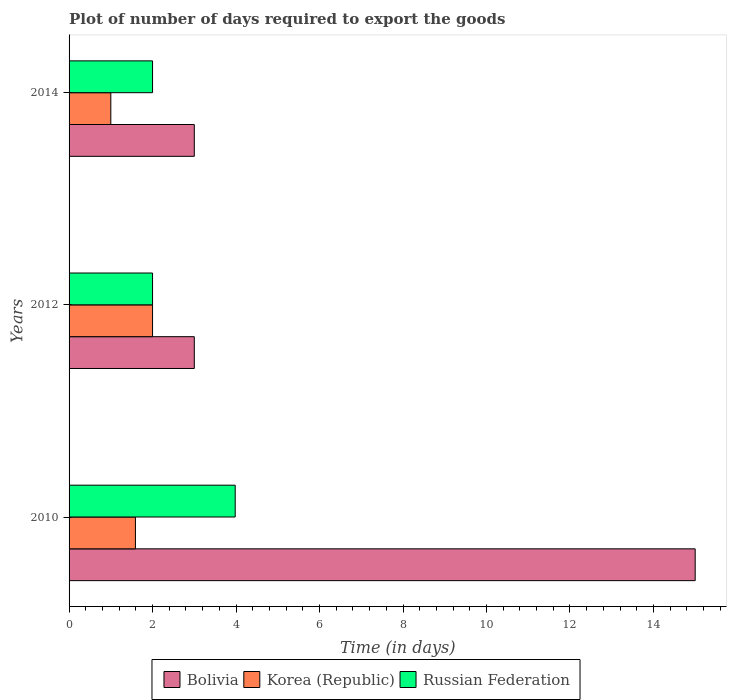How many different coloured bars are there?
Offer a very short reply. 3. How many groups of bars are there?
Your answer should be very brief. 3. How many bars are there on the 1st tick from the top?
Keep it short and to the point. 3. What is the label of the 1st group of bars from the top?
Your answer should be compact. 2014. In how many cases, is the number of bars for a given year not equal to the number of legend labels?
Give a very brief answer. 0. Across all years, what is the maximum time required to export goods in Bolivia?
Make the answer very short. 15. Across all years, what is the minimum time required to export goods in Russian Federation?
Your answer should be compact. 2. What is the total time required to export goods in Bolivia in the graph?
Provide a succinct answer. 21. What is the average time required to export goods in Russian Federation per year?
Provide a short and direct response. 2.66. In the year 2012, what is the difference between the time required to export goods in Bolivia and time required to export goods in Korea (Republic)?
Keep it short and to the point. 1. What is the ratio of the time required to export goods in Russian Federation in 2010 to that in 2014?
Your answer should be compact. 1.99. Is the sum of the time required to export goods in Bolivia in 2010 and 2014 greater than the maximum time required to export goods in Russian Federation across all years?
Your answer should be very brief. Yes. What does the 1st bar from the top in 2014 represents?
Keep it short and to the point. Russian Federation. How many bars are there?
Your answer should be compact. 9. What is the difference between two consecutive major ticks on the X-axis?
Make the answer very short. 2. Does the graph contain grids?
Ensure brevity in your answer.  No. Where does the legend appear in the graph?
Your answer should be very brief. Bottom center. How many legend labels are there?
Your answer should be compact. 3. How are the legend labels stacked?
Your answer should be very brief. Horizontal. What is the title of the graph?
Your response must be concise. Plot of number of days required to export the goods. Does "Uganda" appear as one of the legend labels in the graph?
Your answer should be compact. No. What is the label or title of the X-axis?
Your response must be concise. Time (in days). What is the label or title of the Y-axis?
Ensure brevity in your answer.  Years. What is the Time (in days) in Korea (Republic) in 2010?
Your answer should be compact. 1.59. What is the Time (in days) in Russian Federation in 2010?
Offer a terse response. 3.98. What is the Time (in days) in Russian Federation in 2012?
Provide a succinct answer. 2. What is the Time (in days) of Bolivia in 2014?
Your answer should be very brief. 3. What is the Time (in days) of Russian Federation in 2014?
Ensure brevity in your answer.  2. Across all years, what is the maximum Time (in days) of Russian Federation?
Provide a succinct answer. 3.98. Across all years, what is the minimum Time (in days) of Bolivia?
Ensure brevity in your answer.  3. Across all years, what is the minimum Time (in days) of Russian Federation?
Your answer should be compact. 2. What is the total Time (in days) in Korea (Republic) in the graph?
Offer a very short reply. 4.59. What is the total Time (in days) of Russian Federation in the graph?
Provide a short and direct response. 7.98. What is the difference between the Time (in days) in Korea (Republic) in 2010 and that in 2012?
Offer a very short reply. -0.41. What is the difference between the Time (in days) of Russian Federation in 2010 and that in 2012?
Ensure brevity in your answer.  1.98. What is the difference between the Time (in days) of Korea (Republic) in 2010 and that in 2014?
Provide a succinct answer. 0.59. What is the difference between the Time (in days) in Russian Federation in 2010 and that in 2014?
Ensure brevity in your answer.  1.98. What is the difference between the Time (in days) in Bolivia in 2012 and that in 2014?
Offer a very short reply. 0. What is the difference between the Time (in days) in Korea (Republic) in 2012 and that in 2014?
Offer a very short reply. 1. What is the difference between the Time (in days) in Russian Federation in 2012 and that in 2014?
Offer a terse response. 0. What is the difference between the Time (in days) in Bolivia in 2010 and the Time (in days) in Korea (Republic) in 2012?
Provide a succinct answer. 13. What is the difference between the Time (in days) of Bolivia in 2010 and the Time (in days) of Russian Federation in 2012?
Your answer should be very brief. 13. What is the difference between the Time (in days) of Korea (Republic) in 2010 and the Time (in days) of Russian Federation in 2012?
Give a very brief answer. -0.41. What is the difference between the Time (in days) of Bolivia in 2010 and the Time (in days) of Korea (Republic) in 2014?
Provide a short and direct response. 14. What is the difference between the Time (in days) in Korea (Republic) in 2010 and the Time (in days) in Russian Federation in 2014?
Provide a short and direct response. -0.41. What is the difference between the Time (in days) in Bolivia in 2012 and the Time (in days) in Russian Federation in 2014?
Offer a terse response. 1. What is the average Time (in days) in Bolivia per year?
Offer a terse response. 7. What is the average Time (in days) of Korea (Republic) per year?
Give a very brief answer. 1.53. What is the average Time (in days) in Russian Federation per year?
Your response must be concise. 2.66. In the year 2010, what is the difference between the Time (in days) of Bolivia and Time (in days) of Korea (Republic)?
Your answer should be compact. 13.41. In the year 2010, what is the difference between the Time (in days) in Bolivia and Time (in days) in Russian Federation?
Your answer should be compact. 11.02. In the year 2010, what is the difference between the Time (in days) in Korea (Republic) and Time (in days) in Russian Federation?
Your response must be concise. -2.39. In the year 2014, what is the difference between the Time (in days) in Korea (Republic) and Time (in days) in Russian Federation?
Your answer should be very brief. -1. What is the ratio of the Time (in days) of Korea (Republic) in 2010 to that in 2012?
Offer a very short reply. 0.8. What is the ratio of the Time (in days) in Russian Federation in 2010 to that in 2012?
Your answer should be compact. 1.99. What is the ratio of the Time (in days) of Bolivia in 2010 to that in 2014?
Offer a terse response. 5. What is the ratio of the Time (in days) in Korea (Republic) in 2010 to that in 2014?
Your response must be concise. 1.59. What is the ratio of the Time (in days) in Russian Federation in 2010 to that in 2014?
Make the answer very short. 1.99. What is the ratio of the Time (in days) in Bolivia in 2012 to that in 2014?
Make the answer very short. 1. What is the ratio of the Time (in days) in Korea (Republic) in 2012 to that in 2014?
Provide a short and direct response. 2. What is the difference between the highest and the second highest Time (in days) in Bolivia?
Provide a short and direct response. 12. What is the difference between the highest and the second highest Time (in days) in Korea (Republic)?
Offer a terse response. 0.41. What is the difference between the highest and the second highest Time (in days) in Russian Federation?
Your answer should be compact. 1.98. What is the difference between the highest and the lowest Time (in days) of Russian Federation?
Provide a succinct answer. 1.98. 